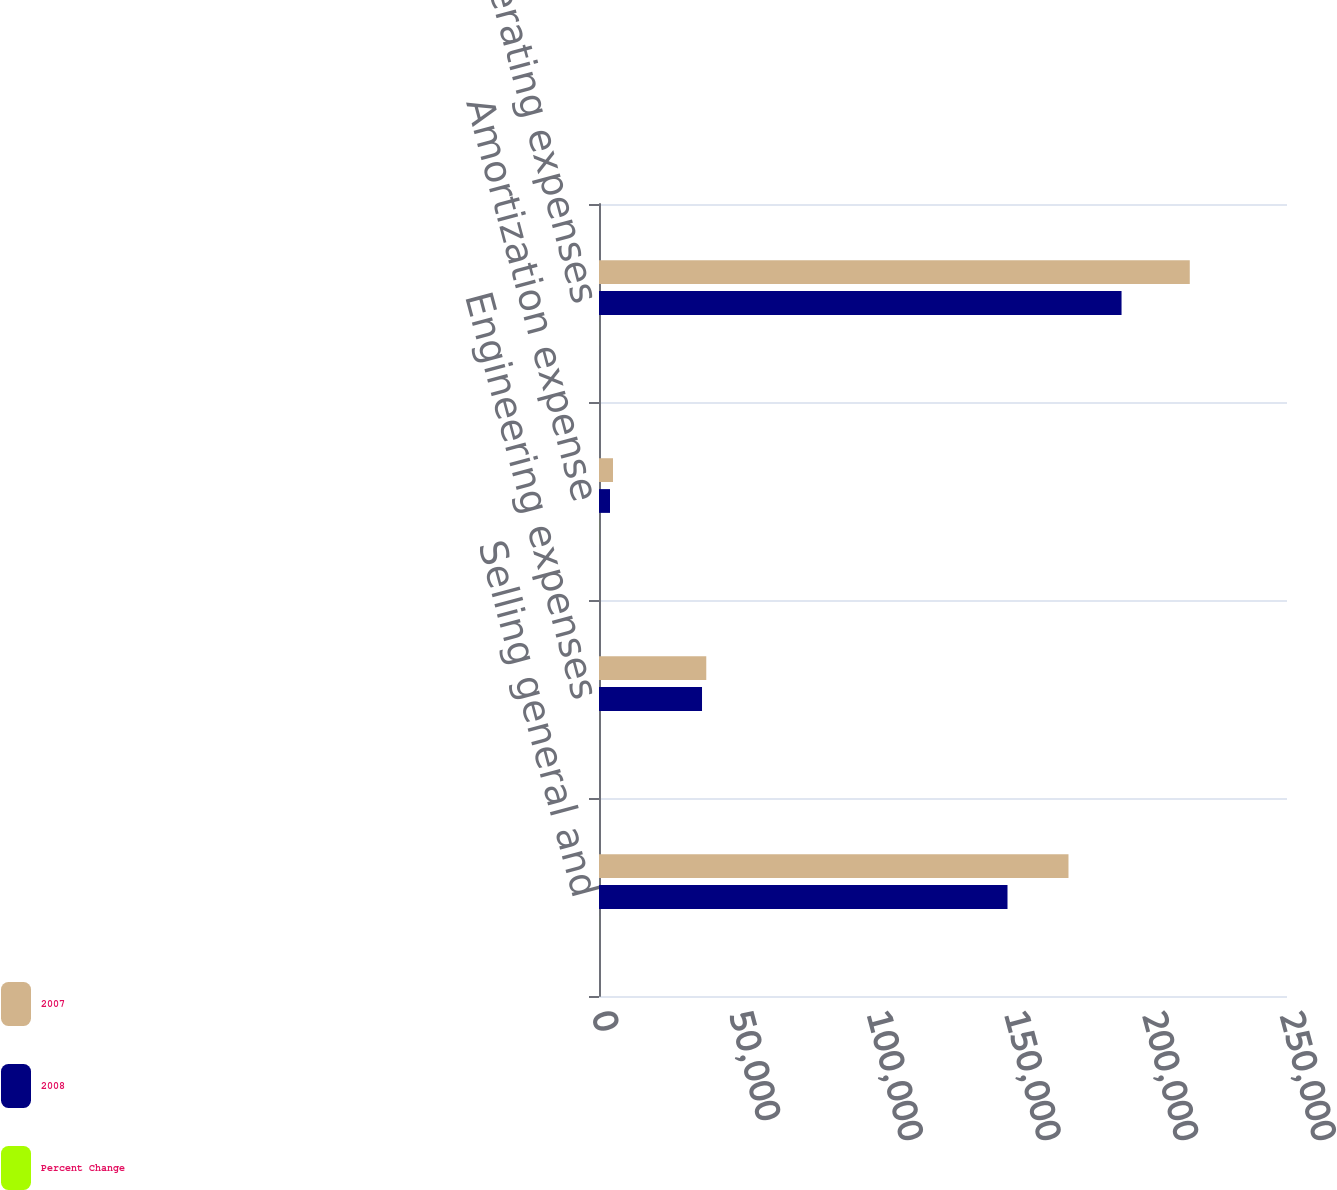<chart> <loc_0><loc_0><loc_500><loc_500><stacked_bar_chart><ecel><fcel>Selling general and<fcel>Engineering expenses<fcel>Amortization expense<fcel>Total operating expenses<nl><fcel>2007<fcel>170597<fcel>38981<fcel>5092<fcel>214670<nl><fcel>2008<fcel>148437<fcel>37434<fcel>4007<fcel>189878<nl><fcel>Percent Change<fcel>14.9<fcel>4.1<fcel>27.1<fcel>13.1<nl></chart> 